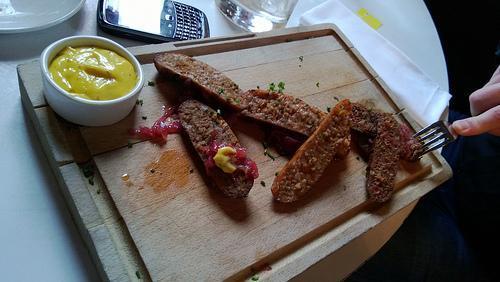How many phones are in the picture?
Give a very brief answer. 1. 